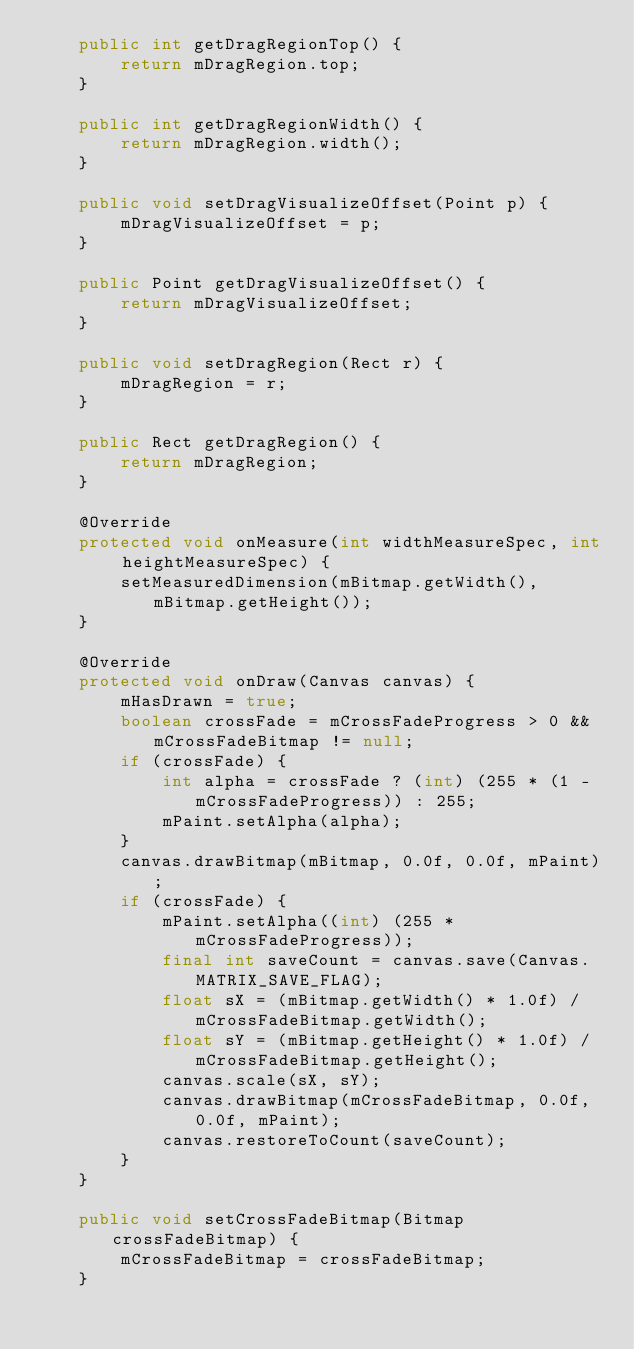Convert code to text. <code><loc_0><loc_0><loc_500><loc_500><_Java_>    public int getDragRegionTop() {
        return mDragRegion.top;
    }

    public int getDragRegionWidth() {
        return mDragRegion.width();
    }

    public void setDragVisualizeOffset(Point p) {
        mDragVisualizeOffset = p;
    }

    public Point getDragVisualizeOffset() {
        return mDragVisualizeOffset;
    }

    public void setDragRegion(Rect r) {
        mDragRegion = r;
    }

    public Rect getDragRegion() {
        return mDragRegion;
    }

    @Override
    protected void onMeasure(int widthMeasureSpec, int heightMeasureSpec) {
        setMeasuredDimension(mBitmap.getWidth(), mBitmap.getHeight());
    }

    @Override
    protected void onDraw(Canvas canvas) {
        mHasDrawn = true;
        boolean crossFade = mCrossFadeProgress > 0 && mCrossFadeBitmap != null;
        if (crossFade) {
            int alpha = crossFade ? (int) (255 * (1 - mCrossFadeProgress)) : 255;
            mPaint.setAlpha(alpha);
        }
        canvas.drawBitmap(mBitmap, 0.0f, 0.0f, mPaint);
        if (crossFade) {
            mPaint.setAlpha((int) (255 * mCrossFadeProgress));
            final int saveCount = canvas.save(Canvas.MATRIX_SAVE_FLAG);
            float sX = (mBitmap.getWidth() * 1.0f) / mCrossFadeBitmap.getWidth();
            float sY = (mBitmap.getHeight() * 1.0f) / mCrossFadeBitmap.getHeight();
            canvas.scale(sX, sY);
            canvas.drawBitmap(mCrossFadeBitmap, 0.0f, 0.0f, mPaint);
            canvas.restoreToCount(saveCount);
        }
    }

    public void setCrossFadeBitmap(Bitmap crossFadeBitmap) {
        mCrossFadeBitmap = crossFadeBitmap;
    }
</code> 